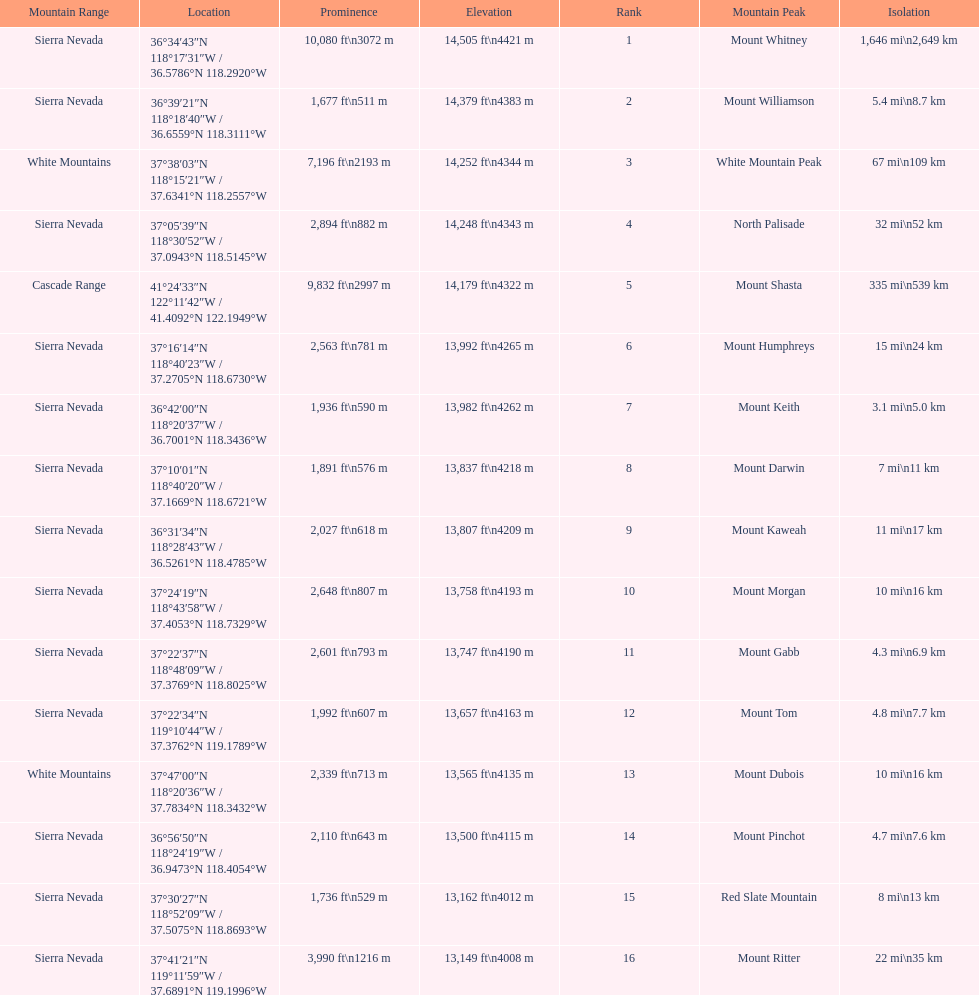What are the prominence lengths higher than 10,000 feet? 10,080 ft\n3072 m. What mountain peak has a prominence of 10,080 feet? Mount Whitney. 